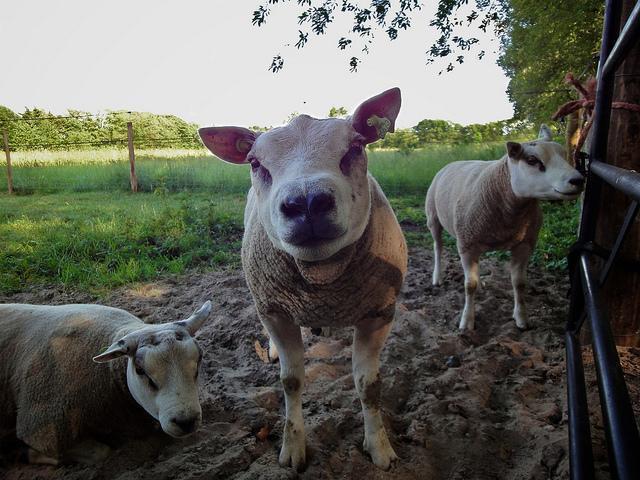How many animals are there?
Give a very brief answer. 3. How many sheep are in the photo?
Give a very brief answer. 3. How many clocks are shown?
Give a very brief answer. 0. 